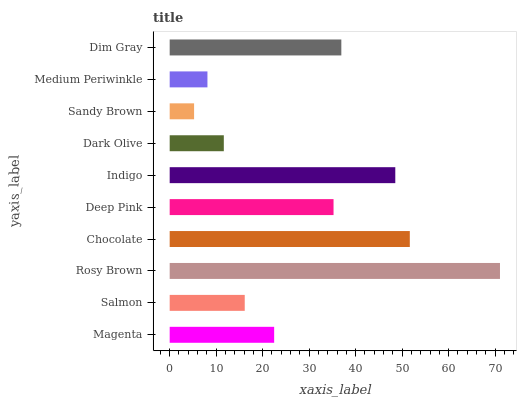Is Sandy Brown the minimum?
Answer yes or no. Yes. Is Rosy Brown the maximum?
Answer yes or no. Yes. Is Salmon the minimum?
Answer yes or no. No. Is Salmon the maximum?
Answer yes or no. No. Is Magenta greater than Salmon?
Answer yes or no. Yes. Is Salmon less than Magenta?
Answer yes or no. Yes. Is Salmon greater than Magenta?
Answer yes or no. No. Is Magenta less than Salmon?
Answer yes or no. No. Is Deep Pink the high median?
Answer yes or no. Yes. Is Magenta the low median?
Answer yes or no. Yes. Is Dim Gray the high median?
Answer yes or no. No. Is Dim Gray the low median?
Answer yes or no. No. 